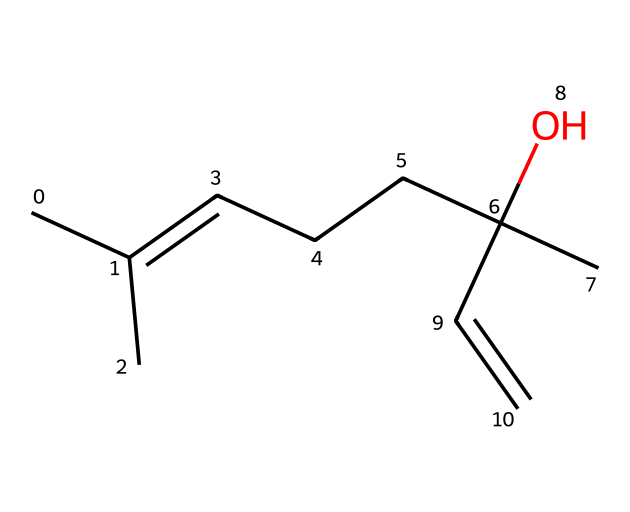How many carbon atoms are in linalool? By analyzing the SMILES representation, we can count the carbon atoms present. Each "C" denotes a carbon, and upon counting, we find there are 10 carbon atoms total.
Answer: 10 What is the functional group present in linalool? In the given structure, the presence of the -OH (hydroxyl) group indicates that linalool has an alcohol functional group, which is key to its properties.
Answer: alcohol How many double bonds are present in linalool? Looking closely at the structure, there is one C=C double bond indicated in the SMILES representation, specifically between two carbon atoms.
Answer: 1 What type of compound is linalool primarily classified as? Due to its structural characteristics and the presence of a hydroxyl group along with carbon chains, linalool is classified as a terpenoid, specifically a monoterpene alcohol.
Answer: terpenoid Does linalool contain any aromatic rings? In examining the provided chemical structure, there are no aromatic rings present; all carbon atoms are part of alkyl chains and contribute to the terpenoid nature.
Answer: no What property of linalool contributes to its use in personal care products? The floral and pleasant scent of linalool, attributed to its specific molecular structure, is the primary property that makes it highly desirable for use in fragrances and personal care products.
Answer: fragrance 